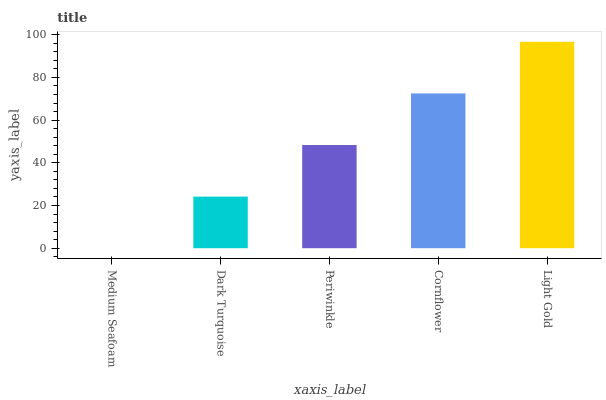Is Medium Seafoam the minimum?
Answer yes or no. Yes. Is Light Gold the maximum?
Answer yes or no. Yes. Is Dark Turquoise the minimum?
Answer yes or no. No. Is Dark Turquoise the maximum?
Answer yes or no. No. Is Dark Turquoise greater than Medium Seafoam?
Answer yes or no. Yes. Is Medium Seafoam less than Dark Turquoise?
Answer yes or no. Yes. Is Medium Seafoam greater than Dark Turquoise?
Answer yes or no. No. Is Dark Turquoise less than Medium Seafoam?
Answer yes or no. No. Is Periwinkle the high median?
Answer yes or no. Yes. Is Periwinkle the low median?
Answer yes or no. Yes. Is Dark Turquoise the high median?
Answer yes or no. No. Is Light Gold the low median?
Answer yes or no. No. 